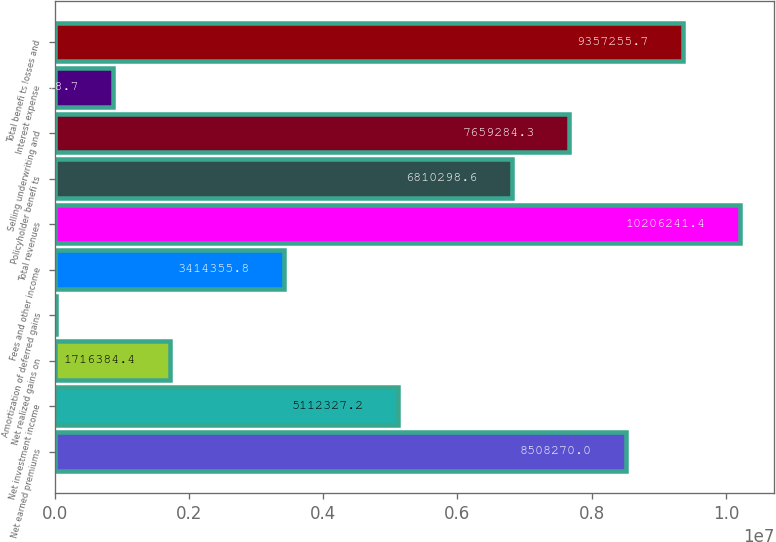<chart> <loc_0><loc_0><loc_500><loc_500><bar_chart><fcel>Net earned premiums<fcel>Net investment income<fcel>Net realized gains on<fcel>Amortization of deferred gains<fcel>Fees and other income<fcel>Total revenues<fcel>Policyholder benefi ts<fcel>Selling underwriting and<fcel>Interest expense<fcel>Total benefi ts losses and<nl><fcel>8.50827e+06<fcel>5.11233e+06<fcel>1.71638e+06<fcel>18413<fcel>3.41436e+06<fcel>1.02062e+07<fcel>6.8103e+06<fcel>7.65928e+06<fcel>867399<fcel>9.35726e+06<nl></chart> 